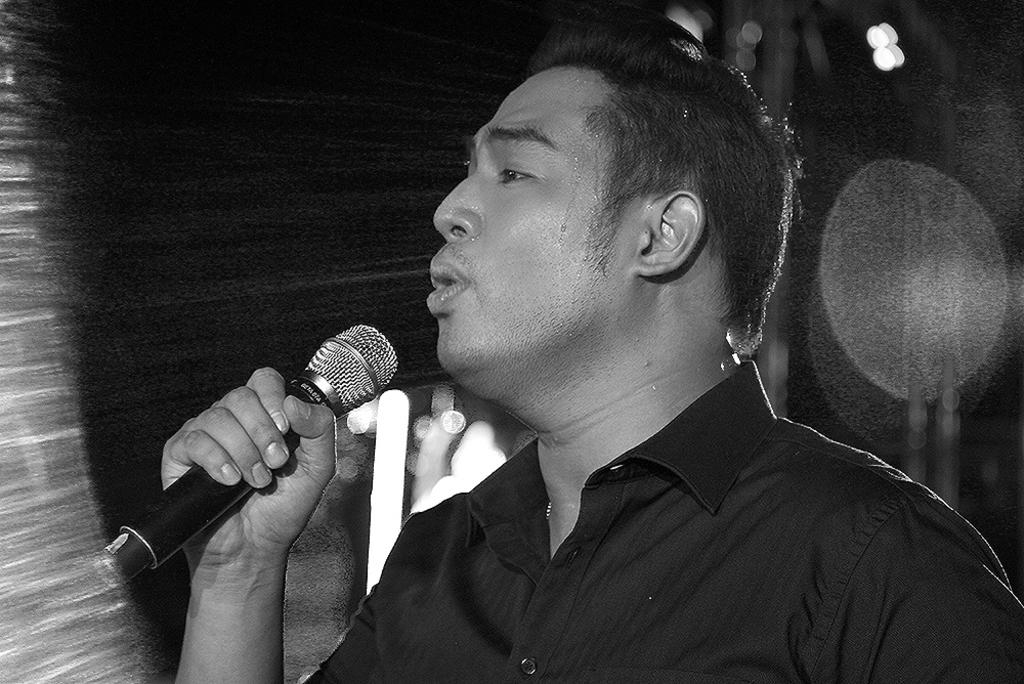What is the main subject of the image? There is a person in the image. What is the person holding in the image? The person is holding a microphone. What is the person doing with the microphone? The person is talking into the microphone. What type of milk is the person drinking from the microphone in the image? There is no milk or drinking activity present in the image; the person is talking into the microphone. 